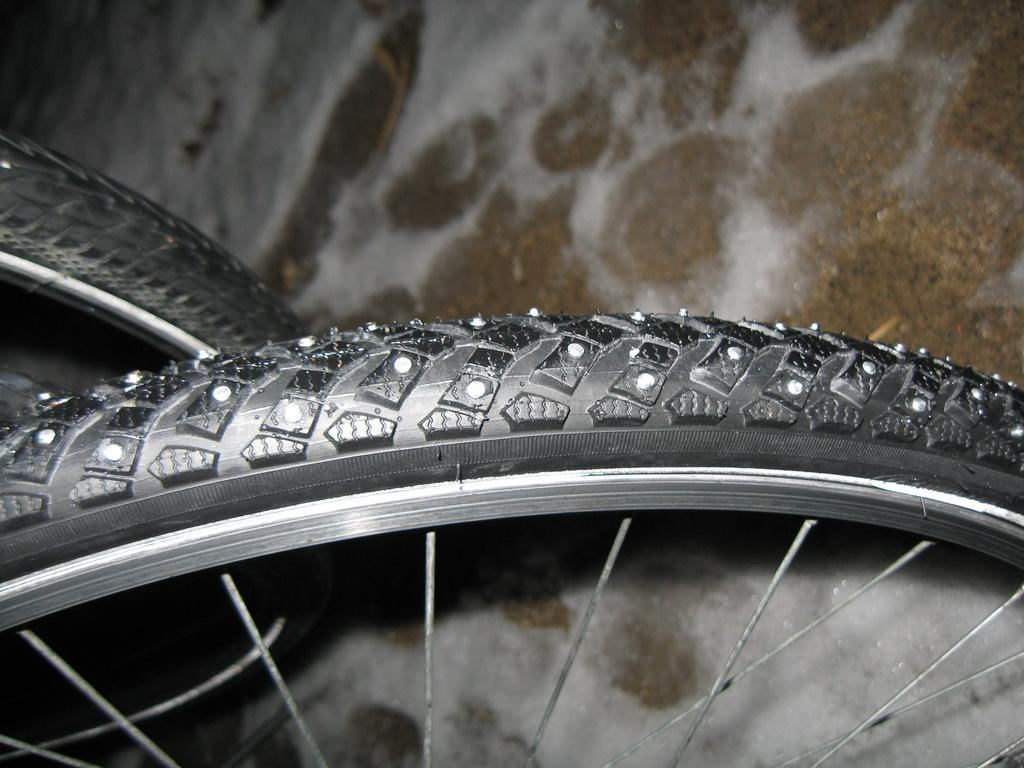What objects are present in the image? There are two bicycle wheels in the image. What color are the tires on the bicycle wheels? The tires on the bicycle wheels are black. How many strings can be seen attached to the bicycle wheels in the image? There are no strings attached to the bicycle wheels in the image. Are there any roses growing near the bicycle wheels in the image? There are no roses present in the image. 